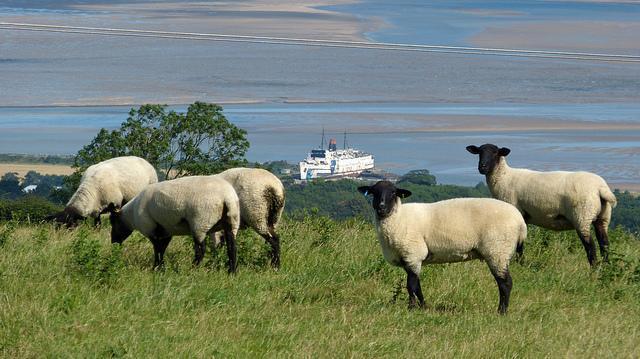How many sheep are in the picture?
Give a very brief answer. 5. 